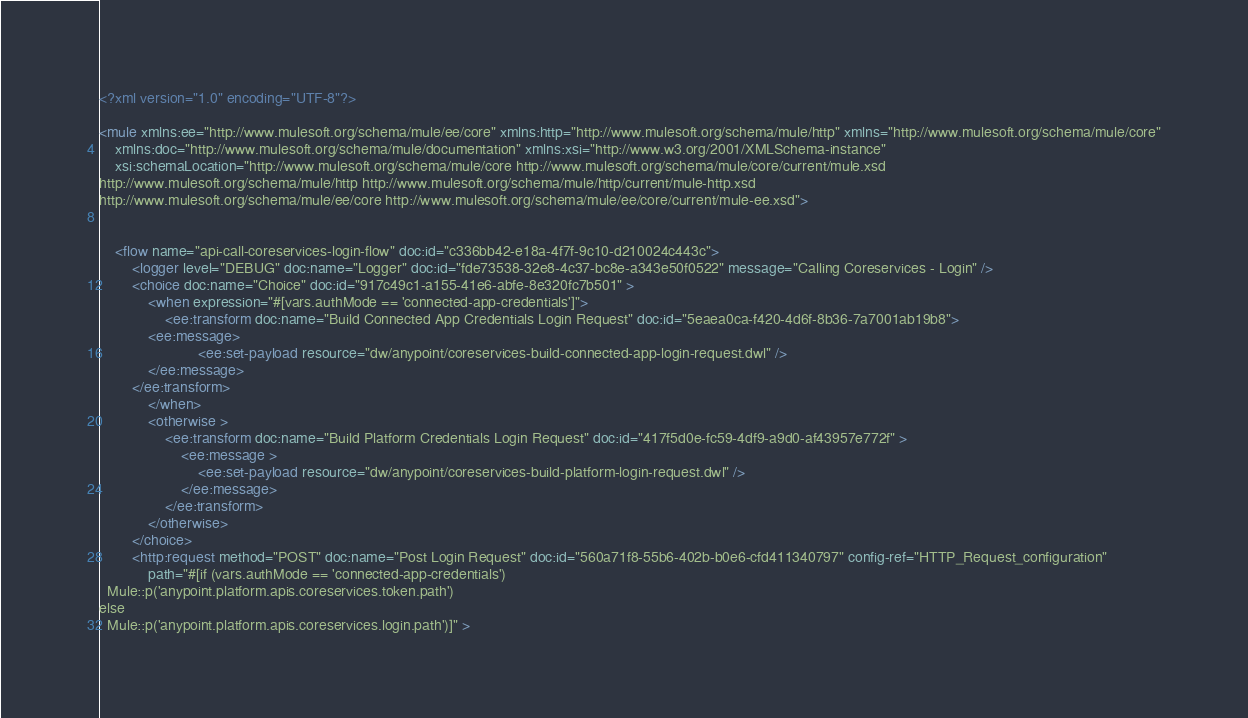Convert code to text. <code><loc_0><loc_0><loc_500><loc_500><_XML_><?xml version="1.0" encoding="UTF-8"?>

<mule xmlns:ee="http://www.mulesoft.org/schema/mule/ee/core" xmlns:http="http://www.mulesoft.org/schema/mule/http" xmlns="http://www.mulesoft.org/schema/mule/core"
	xmlns:doc="http://www.mulesoft.org/schema/mule/documentation" xmlns:xsi="http://www.w3.org/2001/XMLSchema-instance"
	xsi:schemaLocation="http://www.mulesoft.org/schema/mule/core http://www.mulesoft.org/schema/mule/core/current/mule.xsd
http://www.mulesoft.org/schema/mule/http http://www.mulesoft.org/schema/mule/http/current/mule-http.xsd
http://www.mulesoft.org/schema/mule/ee/core http://www.mulesoft.org/schema/mule/ee/core/current/mule-ee.xsd">


	<flow name="api-call-coreservices-login-flow" doc:id="c336bb42-e18a-4f7f-9c10-d210024c443c">
		<logger level="DEBUG" doc:name="Logger" doc:id="fde73538-32e8-4c37-bc8e-a343e50f0522" message="Calling Coreservices - Login" />
		<choice doc:name="Choice" doc:id="917c49c1-a155-41e6-abfe-8e320fc7b501" >
			<when expression="#[vars.authMode == 'connected-app-credentials']">
				<ee:transform doc:name="Build Connected App Credentials Login Request" doc:id="5eaea0ca-f420-4d6f-8b36-7a7001ab19b8">
			<ee:message>
						<ee:set-payload resource="dw/anypoint/coreservices-build-connected-app-login-request.dwl" />
			</ee:message>
		</ee:transform>
			</when>
			<otherwise >
				<ee:transform doc:name="Build Platform Credentials Login Request" doc:id="417f5d0e-fc59-4df9-a9d0-af43957e772f" >
					<ee:message >
						<ee:set-payload resource="dw/anypoint/coreservices-build-platform-login-request.dwl" />
					</ee:message>
				</ee:transform>
			</otherwise>
		</choice>
		<http:request method="POST" doc:name="Post Login Request" doc:id="560a71f8-55b6-402b-b0e6-cfd411340797" config-ref="HTTP_Request_configuration"
			path="#[if (vars.authMode == 'connected-app-credentials')
  Mule::p('anypoint.platform.apis.coreservices.token.path')
else
  Mule::p('anypoint.platform.apis.coreservices.login.path')]" ></code> 